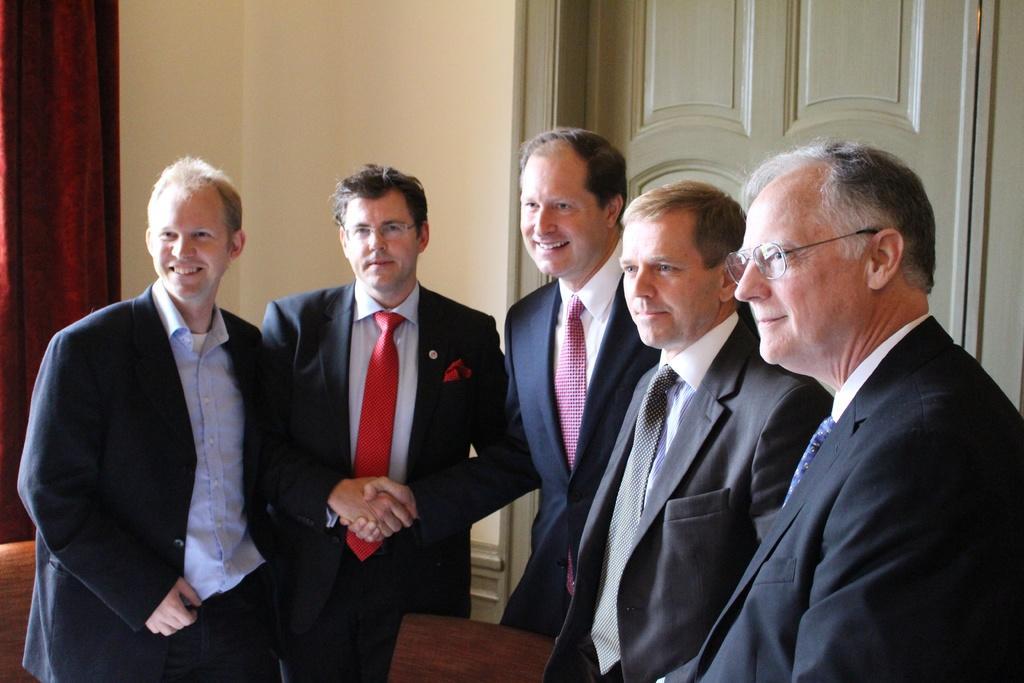Could you give a brief overview of what you see in this image? In this image I can see group of people standing. In front the person is wearing black color blazer, white shirt and red color tie. Background I can see the curtain in red color, wall in cream color and the door is in gray color. 